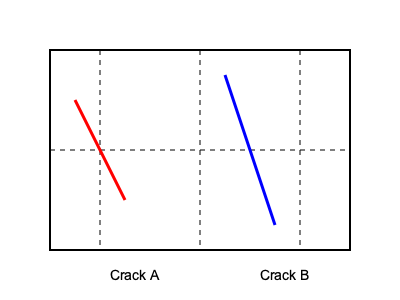Analyze the foundation crack patterns shown in the diagram. Crack A (red) is a diagonal crack with a 45-degree angle, while Crack B (blue) is a vertical crack. Based on these patterns, which crack is more likely to indicate a serious structural issue, and why? To analyze the foundation crack patterns and determine their implications for structural integrity, we need to consider the following steps:

1. Crack orientation:
   - Crack A: Diagonal at a 45-degree angle
   - Crack B: Vertical

2. Typical causes:
   - Diagonal cracks (like Crack A) are often caused by differential settlement, where one part of the foundation is sinking more than another. This can be due to:
     a) Soil issues (e.g., expansive clay)
     b) Poor drainage
     c) Tree roots
   - Vertical cracks (like Crack B) are usually caused by:
     a) Concrete shrinkage during curing
     b) Minor settling

3. Severity assessment:
   - Diagonal cracks are generally more concerning because they indicate uneven stress distribution across the foundation.
   - The 45-degree angle of Crack A suggests significant shear stress, which can compromise the structural integrity of the foundation.
   - Vertical cracks, while not ideal, often result from normal settling or concrete curing processes and are less likely to indicate severe structural issues.

4. Potential consequences:
   - Crack A (diagonal) can lead to:
     a) Further foundation settlement
     b) Structural misalignment
     c) Damage to other parts of the building (walls, floors, roof)
   - Crack B (vertical) is less likely to propagate or cause significant structural issues unless it widens considerably over time.

5. Additional factors to consider:
   - Width of the cracks (not specified in this diagram)
   - Whether the cracks are active (continuing to grow) or dormant
   - The age of the foundation and local soil conditions

Based on this analysis, Crack A (the diagonal crack) is more likely to indicate a serious structural issue due to its orientation and the underlying causes it suggests.
Answer: Crack A (diagonal) is more likely to indicate a serious structural issue due to potential differential settlement and shear stress. 